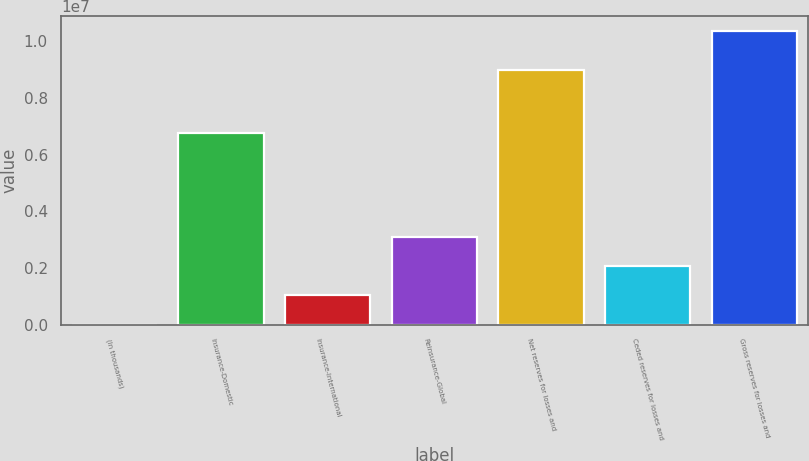Convert chart to OTSL. <chart><loc_0><loc_0><loc_500><loc_500><bar_chart><fcel>(In thousands)<fcel>Insurance-Domestic<fcel>Insurance-International<fcel>Reinsurance-Global<fcel>Net reserves for losses and<fcel>Ceded reserves for losses and<fcel>Gross reserves for losses and<nl><fcel>2014<fcel>6.76737e+06<fcel>1.03878e+06<fcel>3.11232e+06<fcel>8.97064e+06<fcel>2.07555e+06<fcel>1.03697e+07<nl></chart> 